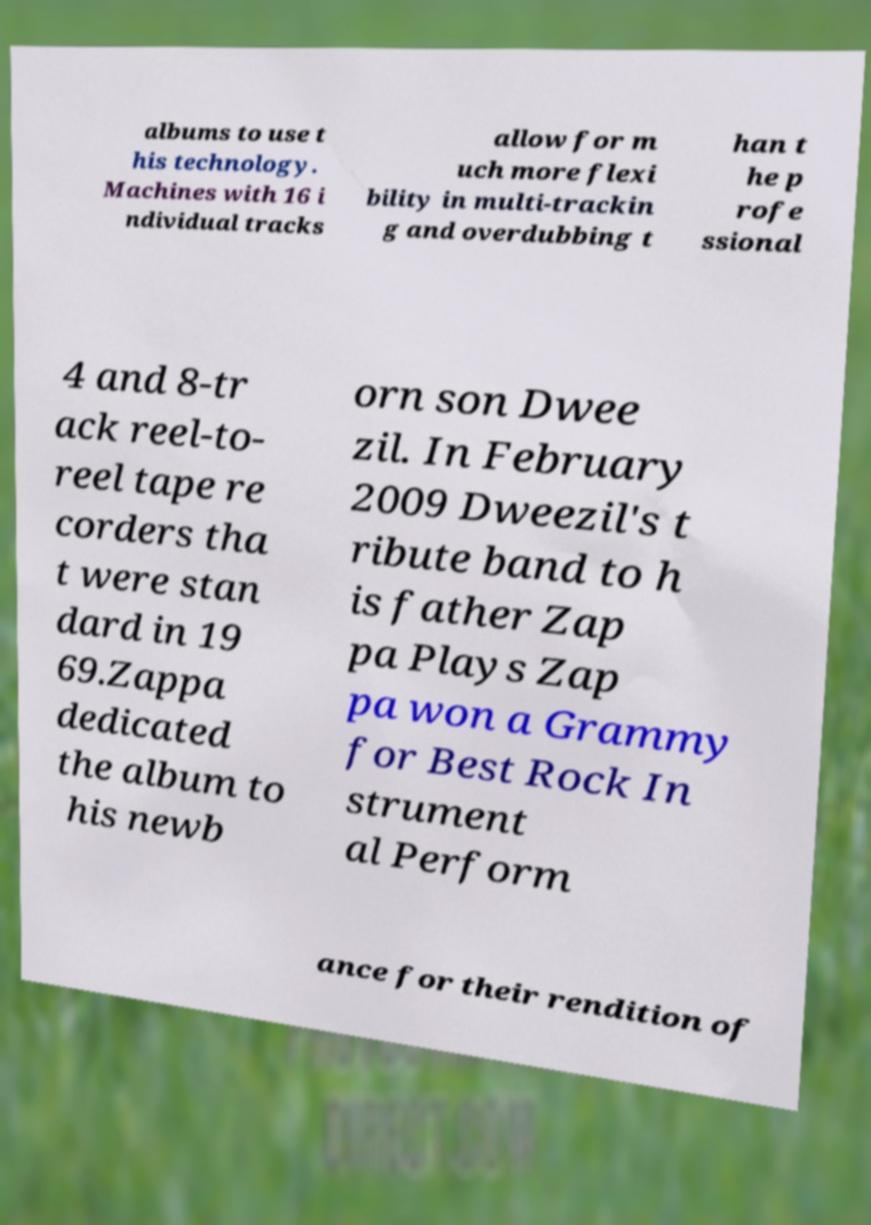I need the written content from this picture converted into text. Can you do that? albums to use t his technology. Machines with 16 i ndividual tracks allow for m uch more flexi bility in multi-trackin g and overdubbing t han t he p rofe ssional 4 and 8-tr ack reel-to- reel tape re corders tha t were stan dard in 19 69.Zappa dedicated the album to his newb orn son Dwee zil. In February 2009 Dweezil's t ribute band to h is father Zap pa Plays Zap pa won a Grammy for Best Rock In strument al Perform ance for their rendition of 